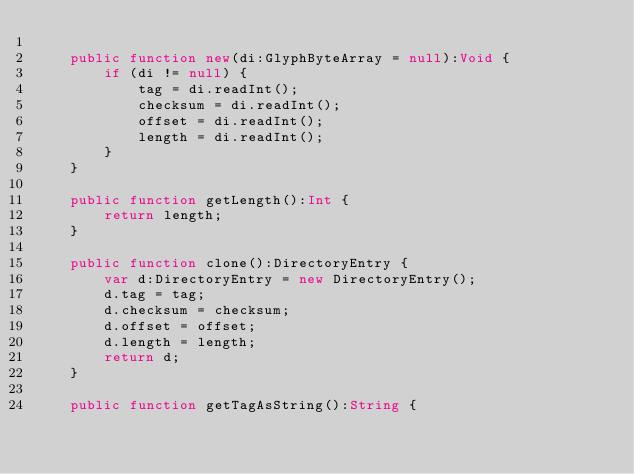<code> <loc_0><loc_0><loc_500><loc_500><_Haxe_>
    public function new(di:GlyphByteArray = null):Void {
        if (di != null) {
            tag = di.readInt();
            checksum = di.readInt();
            offset = di.readInt();
            length = di.readInt();
        }
    }

    public function getLength():Int {
        return length;
    }

    public function clone():DirectoryEntry {
        var d:DirectoryEntry = new DirectoryEntry();
        d.tag = tag;
        d.checksum = checksum;
        d.offset = offset;
        d.length = length;
        return d;
    }

    public function getTagAsString():String {</code> 